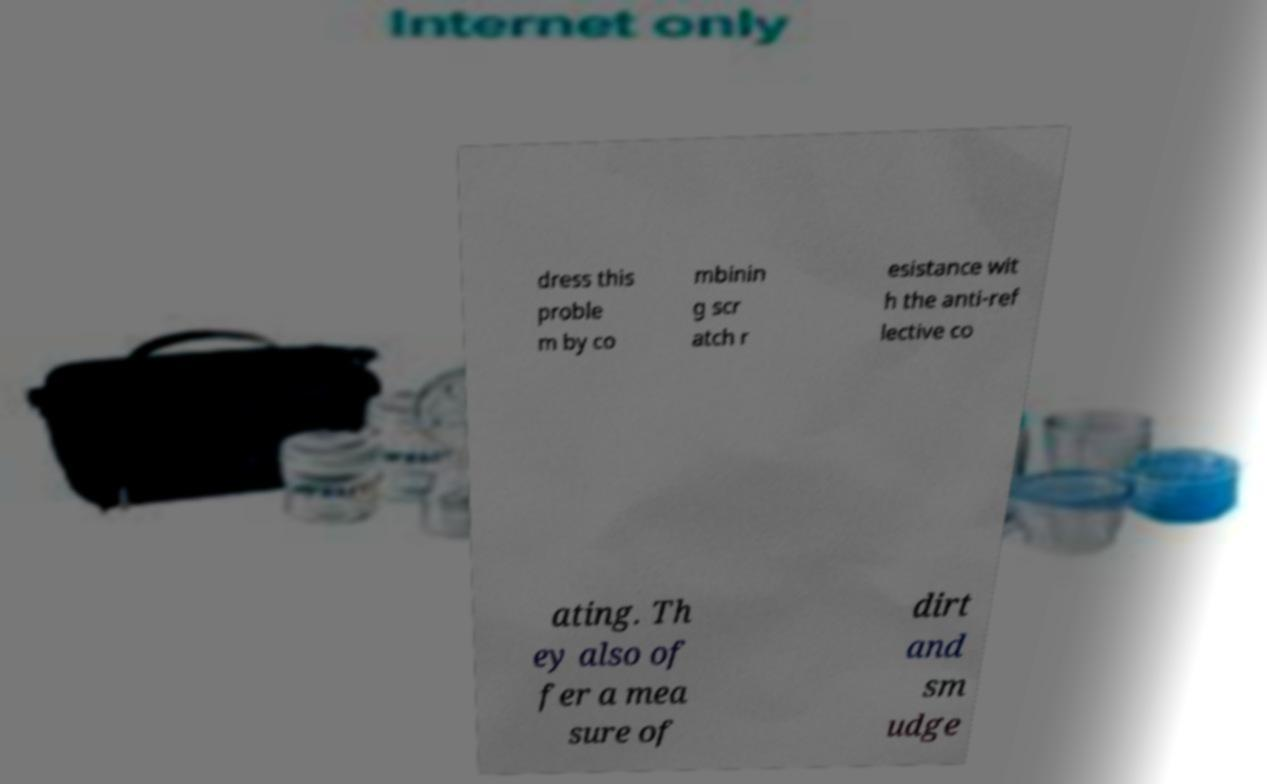Please read and relay the text visible in this image. What does it say? dress this proble m by co mbinin g scr atch r esistance wit h the anti-ref lective co ating. Th ey also of fer a mea sure of dirt and sm udge 